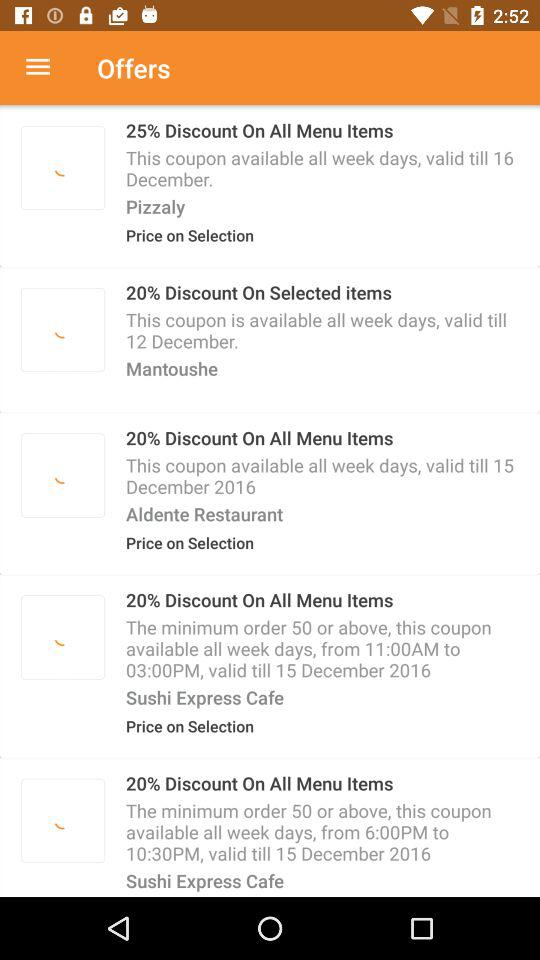On what days is the discounted coupon available at Mantoushe? At Mantoushe, the discounted coupon is available on all days of the week. 